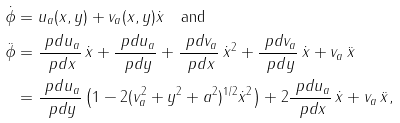Convert formula to latex. <formula><loc_0><loc_0><loc_500><loc_500>\dot { \phi } & = u _ { a } ( x , y ) + v _ { a } ( x , y ) \dot { x } \quad \text {and} \\ \ddot { \phi } & = \frac { \ p d u _ { a } } { \ p d x } \, \dot { x } + \frac { \ p d u _ { a } } { \ p d y } + \frac { \ p d v _ { a } } { \ p d x } \, \dot { x } ^ { 2 } + \frac { \ p d v _ { a } } { \ p d y } \, \dot { x } + v _ { a } \, \ddot { x } \\ & = \frac { \ p d u _ { a } } { \ p d y } \left ( 1 - 2 ( v _ { a } ^ { 2 } + y ^ { 2 } + a ^ { 2 } ) ^ { 1 / 2 } \dot { x } ^ { 2 } \right ) + 2 \frac { \ p d u _ { a } } { \ p d x } \, \dot { x } + v _ { a } \, \ddot { x } ,</formula> 